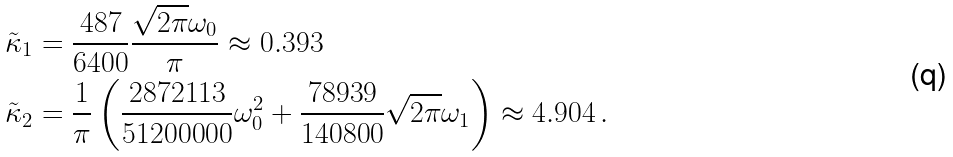<formula> <loc_0><loc_0><loc_500><loc_500>\tilde { \kappa } _ { 1 } & = \frac { 4 8 7 } { 6 4 0 0 } \frac { \sqrt { 2 \pi } \omega _ { 0 } } { \pi } \approx 0 . 3 9 3 \\ \tilde { \kappa } _ { 2 } & = \frac { 1 } { \pi } \left ( \frac { 2 8 7 2 1 1 3 } { 5 1 2 0 0 0 0 0 } \omega _ { 0 } ^ { 2 } + \frac { 7 8 9 3 9 } { 1 4 0 8 0 0 } \sqrt { 2 \pi } \omega _ { 1 } \right ) \approx 4 . 9 0 4 \, .</formula> 